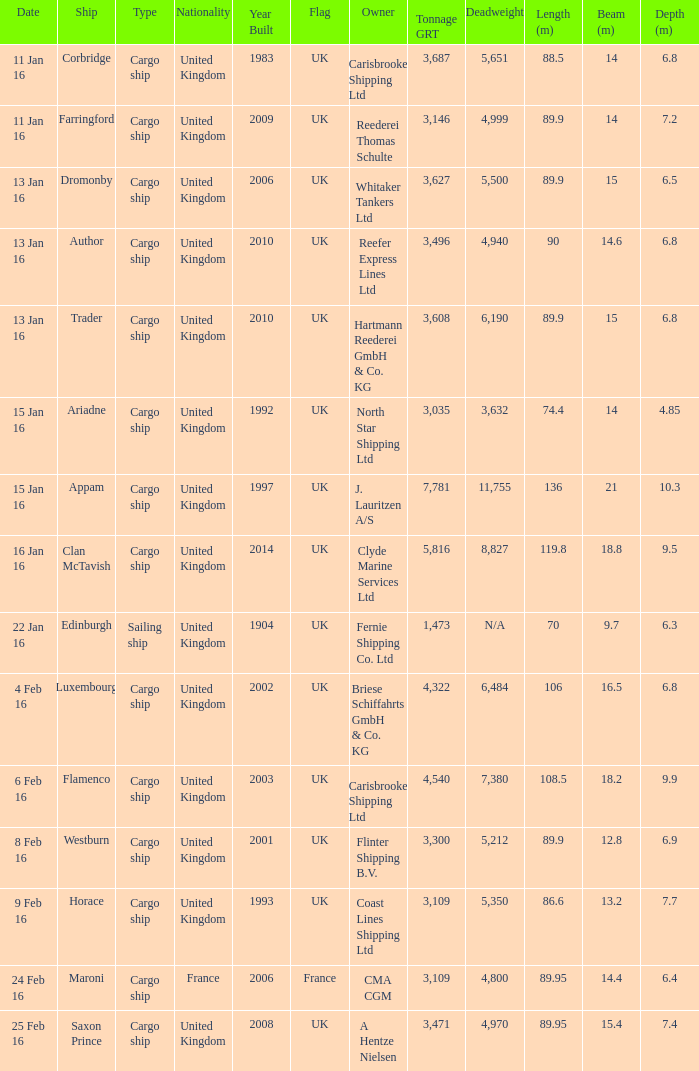On january 16th, which ship had the highest tonnage (grt) among those that were sunk or captured? 5816.0. 